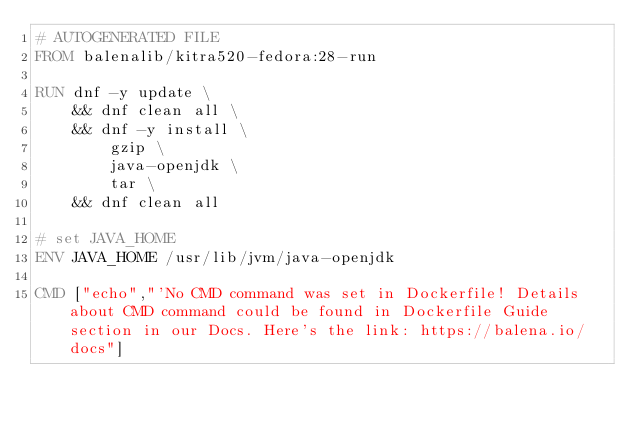Convert code to text. <code><loc_0><loc_0><loc_500><loc_500><_Dockerfile_># AUTOGENERATED FILE
FROM balenalib/kitra520-fedora:28-run

RUN dnf -y update \
	&& dnf clean all \
	&& dnf -y install \
		gzip \
		java-openjdk \
		tar \
	&& dnf clean all

# set JAVA_HOME
ENV JAVA_HOME /usr/lib/jvm/java-openjdk

CMD ["echo","'No CMD command was set in Dockerfile! Details about CMD command could be found in Dockerfile Guide section in our Docs. Here's the link: https://balena.io/docs"]</code> 